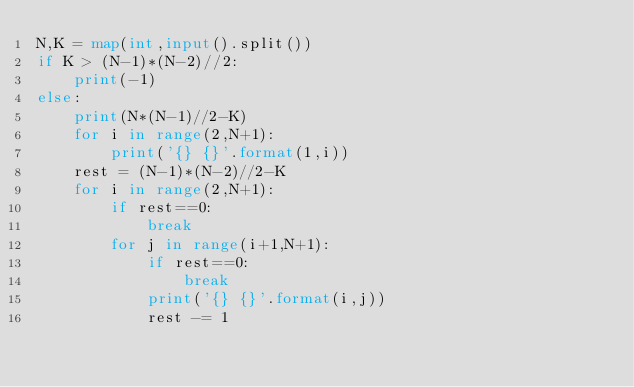Convert code to text. <code><loc_0><loc_0><loc_500><loc_500><_Python_>N,K = map(int,input().split())
if K > (N-1)*(N-2)//2:
    print(-1)
else:
    print(N*(N-1)//2-K)
    for i in range(2,N+1):
        print('{} {}'.format(1,i))
    rest = (N-1)*(N-2)//2-K
    for i in range(2,N+1):
        if rest==0:
            break
        for j in range(i+1,N+1):
            if rest==0:
                break
            print('{} {}'.format(i,j))
            rest -= 1</code> 